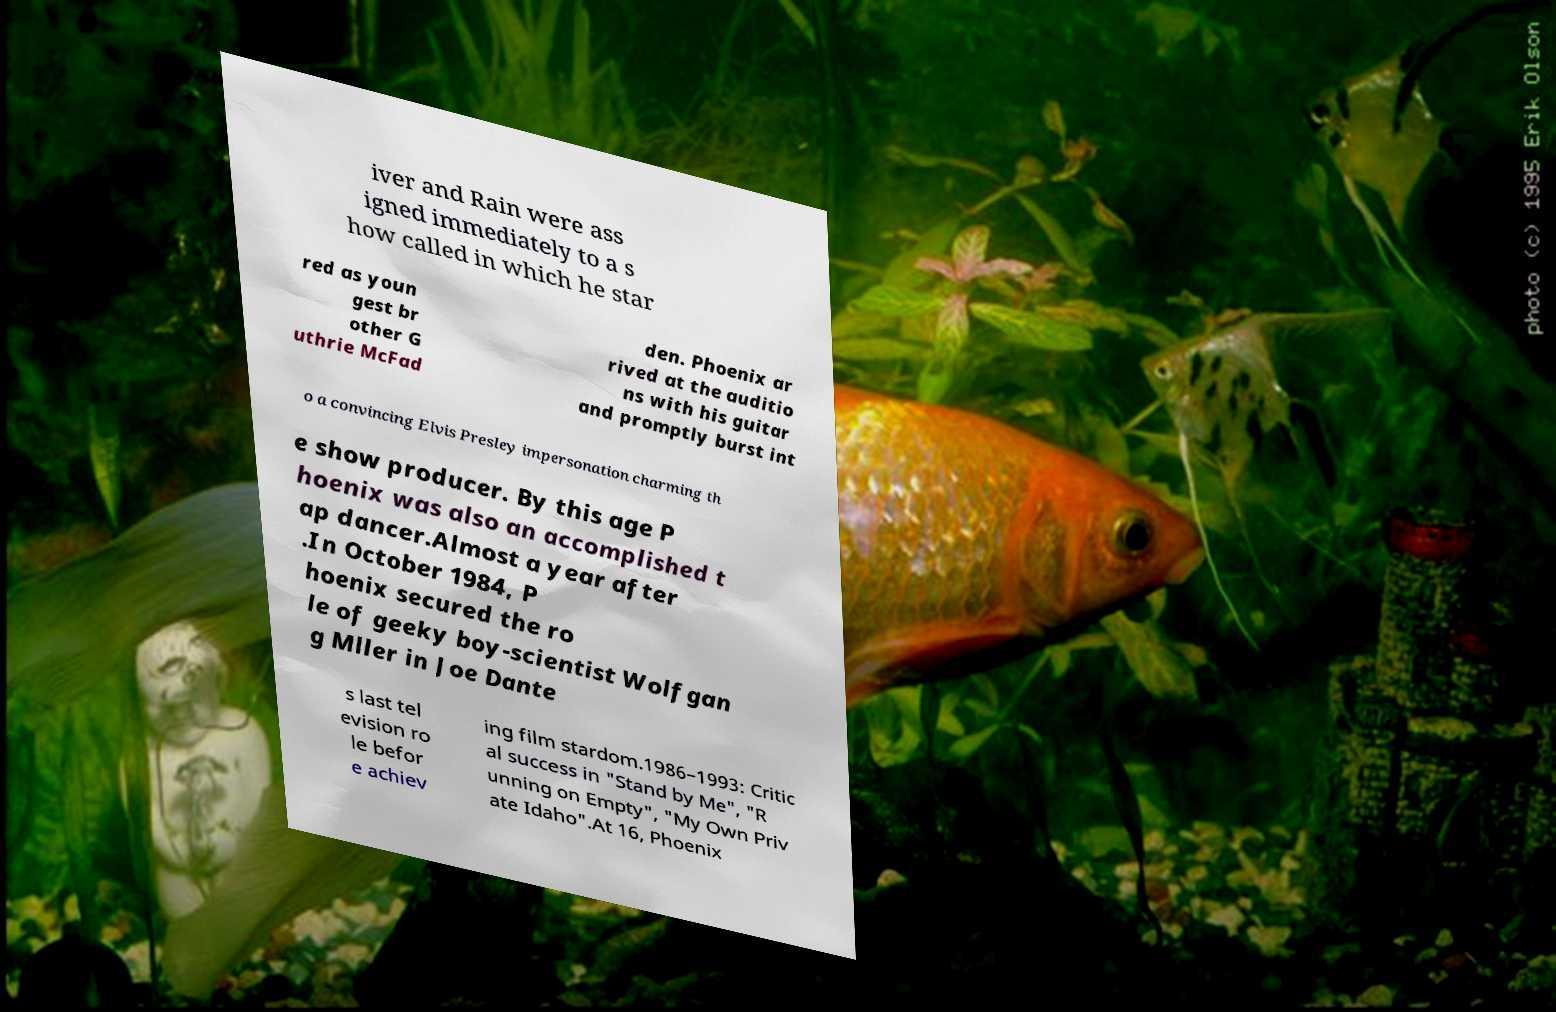Please identify and transcribe the text found in this image. iver and Rain were ass igned immediately to a s how called in which he star red as youn gest br other G uthrie McFad den. Phoenix ar rived at the auditio ns with his guitar and promptly burst int o a convincing Elvis Presley impersonation charming th e show producer. By this age P hoenix was also an accomplished t ap dancer.Almost a year after .In October 1984, P hoenix secured the ro le of geeky boy-scientist Wolfgan g Mller in Joe Dante s last tel evision ro le befor e achiev ing film stardom.1986–1993: Critic al success in "Stand by Me", "R unning on Empty", "My Own Priv ate Idaho".At 16, Phoenix 